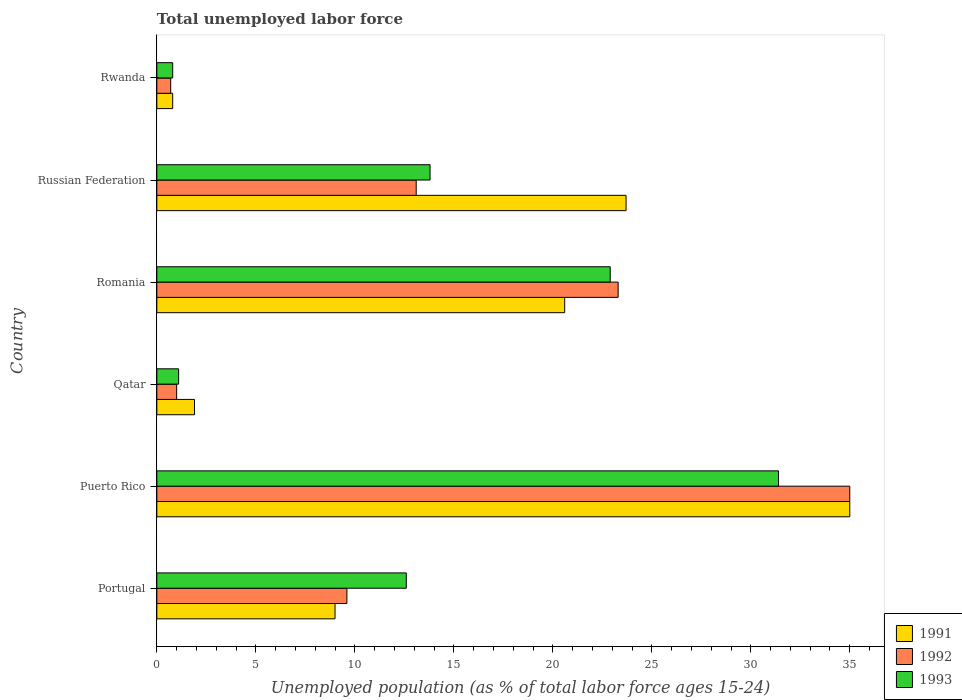How many different coloured bars are there?
Your response must be concise. 3. Are the number of bars on each tick of the Y-axis equal?
Offer a very short reply. Yes. How many bars are there on the 1st tick from the bottom?
Your response must be concise. 3. What is the label of the 6th group of bars from the top?
Offer a very short reply. Portugal. Across all countries, what is the maximum percentage of unemployed population in in 1993?
Your answer should be very brief. 31.4. Across all countries, what is the minimum percentage of unemployed population in in 1991?
Your response must be concise. 0.8. In which country was the percentage of unemployed population in in 1993 maximum?
Provide a short and direct response. Puerto Rico. In which country was the percentage of unemployed population in in 1993 minimum?
Give a very brief answer. Rwanda. What is the total percentage of unemployed population in in 1992 in the graph?
Your response must be concise. 82.7. What is the difference between the percentage of unemployed population in in 1992 in Russian Federation and that in Rwanda?
Your answer should be very brief. 12.4. What is the difference between the percentage of unemployed population in in 1992 in Romania and the percentage of unemployed population in in 1991 in Rwanda?
Offer a very short reply. 22.5. What is the average percentage of unemployed population in in 1991 per country?
Offer a terse response. 15.17. What is the difference between the percentage of unemployed population in in 1993 and percentage of unemployed population in in 1991 in Puerto Rico?
Offer a terse response. -3.6. In how many countries, is the percentage of unemployed population in in 1993 greater than 32 %?
Your response must be concise. 0. What is the ratio of the percentage of unemployed population in in 1993 in Romania to that in Rwanda?
Your answer should be compact. 28.62. Is the percentage of unemployed population in in 1992 in Qatar less than that in Romania?
Offer a terse response. Yes. Is the difference between the percentage of unemployed population in in 1993 in Portugal and Puerto Rico greater than the difference between the percentage of unemployed population in in 1991 in Portugal and Puerto Rico?
Ensure brevity in your answer.  Yes. What is the difference between the highest and the second highest percentage of unemployed population in in 1992?
Offer a terse response. 11.7. What is the difference between the highest and the lowest percentage of unemployed population in in 1991?
Provide a short and direct response. 34.2. What does the 3rd bar from the top in Rwanda represents?
Ensure brevity in your answer.  1991. How many countries are there in the graph?
Provide a succinct answer. 6. Are the values on the major ticks of X-axis written in scientific E-notation?
Your answer should be very brief. No. Does the graph contain any zero values?
Provide a succinct answer. No. Where does the legend appear in the graph?
Offer a terse response. Bottom right. How many legend labels are there?
Make the answer very short. 3. What is the title of the graph?
Offer a very short reply. Total unemployed labor force. Does "2015" appear as one of the legend labels in the graph?
Your response must be concise. No. What is the label or title of the X-axis?
Keep it short and to the point. Unemployed population (as % of total labor force ages 15-24). What is the Unemployed population (as % of total labor force ages 15-24) of 1991 in Portugal?
Provide a succinct answer. 9. What is the Unemployed population (as % of total labor force ages 15-24) of 1992 in Portugal?
Your answer should be very brief. 9.6. What is the Unemployed population (as % of total labor force ages 15-24) in 1993 in Portugal?
Give a very brief answer. 12.6. What is the Unemployed population (as % of total labor force ages 15-24) of 1992 in Puerto Rico?
Provide a succinct answer. 35. What is the Unemployed population (as % of total labor force ages 15-24) of 1993 in Puerto Rico?
Ensure brevity in your answer.  31.4. What is the Unemployed population (as % of total labor force ages 15-24) of 1991 in Qatar?
Provide a succinct answer. 1.9. What is the Unemployed population (as % of total labor force ages 15-24) of 1993 in Qatar?
Give a very brief answer. 1.1. What is the Unemployed population (as % of total labor force ages 15-24) in 1991 in Romania?
Offer a very short reply. 20.6. What is the Unemployed population (as % of total labor force ages 15-24) in 1992 in Romania?
Offer a terse response. 23.3. What is the Unemployed population (as % of total labor force ages 15-24) in 1993 in Romania?
Give a very brief answer. 22.9. What is the Unemployed population (as % of total labor force ages 15-24) in 1991 in Russian Federation?
Your response must be concise. 23.7. What is the Unemployed population (as % of total labor force ages 15-24) in 1992 in Russian Federation?
Your answer should be very brief. 13.1. What is the Unemployed population (as % of total labor force ages 15-24) of 1993 in Russian Federation?
Give a very brief answer. 13.8. What is the Unemployed population (as % of total labor force ages 15-24) in 1991 in Rwanda?
Offer a terse response. 0.8. What is the Unemployed population (as % of total labor force ages 15-24) in 1992 in Rwanda?
Give a very brief answer. 0.7. What is the Unemployed population (as % of total labor force ages 15-24) of 1993 in Rwanda?
Make the answer very short. 0.8. Across all countries, what is the maximum Unemployed population (as % of total labor force ages 15-24) in 1991?
Your answer should be compact. 35. Across all countries, what is the maximum Unemployed population (as % of total labor force ages 15-24) in 1993?
Make the answer very short. 31.4. Across all countries, what is the minimum Unemployed population (as % of total labor force ages 15-24) in 1991?
Your answer should be very brief. 0.8. Across all countries, what is the minimum Unemployed population (as % of total labor force ages 15-24) of 1992?
Offer a very short reply. 0.7. Across all countries, what is the minimum Unemployed population (as % of total labor force ages 15-24) of 1993?
Give a very brief answer. 0.8. What is the total Unemployed population (as % of total labor force ages 15-24) of 1991 in the graph?
Offer a terse response. 91. What is the total Unemployed population (as % of total labor force ages 15-24) of 1992 in the graph?
Offer a very short reply. 82.7. What is the total Unemployed population (as % of total labor force ages 15-24) of 1993 in the graph?
Ensure brevity in your answer.  82.6. What is the difference between the Unemployed population (as % of total labor force ages 15-24) in 1991 in Portugal and that in Puerto Rico?
Provide a short and direct response. -26. What is the difference between the Unemployed population (as % of total labor force ages 15-24) in 1992 in Portugal and that in Puerto Rico?
Give a very brief answer. -25.4. What is the difference between the Unemployed population (as % of total labor force ages 15-24) of 1993 in Portugal and that in Puerto Rico?
Your response must be concise. -18.8. What is the difference between the Unemployed population (as % of total labor force ages 15-24) of 1991 in Portugal and that in Qatar?
Offer a terse response. 7.1. What is the difference between the Unemployed population (as % of total labor force ages 15-24) in 1991 in Portugal and that in Romania?
Keep it short and to the point. -11.6. What is the difference between the Unemployed population (as % of total labor force ages 15-24) of 1992 in Portugal and that in Romania?
Your response must be concise. -13.7. What is the difference between the Unemployed population (as % of total labor force ages 15-24) in 1993 in Portugal and that in Romania?
Offer a terse response. -10.3. What is the difference between the Unemployed population (as % of total labor force ages 15-24) of 1991 in Portugal and that in Russian Federation?
Provide a short and direct response. -14.7. What is the difference between the Unemployed population (as % of total labor force ages 15-24) of 1992 in Portugal and that in Russian Federation?
Keep it short and to the point. -3.5. What is the difference between the Unemployed population (as % of total labor force ages 15-24) of 1991 in Portugal and that in Rwanda?
Make the answer very short. 8.2. What is the difference between the Unemployed population (as % of total labor force ages 15-24) of 1991 in Puerto Rico and that in Qatar?
Offer a terse response. 33.1. What is the difference between the Unemployed population (as % of total labor force ages 15-24) of 1993 in Puerto Rico and that in Qatar?
Make the answer very short. 30.3. What is the difference between the Unemployed population (as % of total labor force ages 15-24) of 1991 in Puerto Rico and that in Romania?
Your response must be concise. 14.4. What is the difference between the Unemployed population (as % of total labor force ages 15-24) of 1992 in Puerto Rico and that in Romania?
Provide a succinct answer. 11.7. What is the difference between the Unemployed population (as % of total labor force ages 15-24) in 1993 in Puerto Rico and that in Romania?
Your response must be concise. 8.5. What is the difference between the Unemployed population (as % of total labor force ages 15-24) in 1991 in Puerto Rico and that in Russian Federation?
Offer a terse response. 11.3. What is the difference between the Unemployed population (as % of total labor force ages 15-24) in 1992 in Puerto Rico and that in Russian Federation?
Your answer should be very brief. 21.9. What is the difference between the Unemployed population (as % of total labor force ages 15-24) of 1991 in Puerto Rico and that in Rwanda?
Make the answer very short. 34.2. What is the difference between the Unemployed population (as % of total labor force ages 15-24) of 1992 in Puerto Rico and that in Rwanda?
Your answer should be compact. 34.3. What is the difference between the Unemployed population (as % of total labor force ages 15-24) of 1993 in Puerto Rico and that in Rwanda?
Your answer should be compact. 30.6. What is the difference between the Unemployed population (as % of total labor force ages 15-24) of 1991 in Qatar and that in Romania?
Give a very brief answer. -18.7. What is the difference between the Unemployed population (as % of total labor force ages 15-24) in 1992 in Qatar and that in Romania?
Your response must be concise. -22.3. What is the difference between the Unemployed population (as % of total labor force ages 15-24) in 1993 in Qatar and that in Romania?
Make the answer very short. -21.8. What is the difference between the Unemployed population (as % of total labor force ages 15-24) in 1991 in Qatar and that in Russian Federation?
Your response must be concise. -21.8. What is the difference between the Unemployed population (as % of total labor force ages 15-24) in 1993 in Qatar and that in Russian Federation?
Your answer should be compact. -12.7. What is the difference between the Unemployed population (as % of total labor force ages 15-24) of 1991 in Qatar and that in Rwanda?
Keep it short and to the point. 1.1. What is the difference between the Unemployed population (as % of total labor force ages 15-24) of 1991 in Romania and that in Russian Federation?
Give a very brief answer. -3.1. What is the difference between the Unemployed population (as % of total labor force ages 15-24) in 1993 in Romania and that in Russian Federation?
Provide a short and direct response. 9.1. What is the difference between the Unemployed population (as % of total labor force ages 15-24) in 1991 in Romania and that in Rwanda?
Offer a terse response. 19.8. What is the difference between the Unemployed population (as % of total labor force ages 15-24) in 1992 in Romania and that in Rwanda?
Provide a succinct answer. 22.6. What is the difference between the Unemployed population (as % of total labor force ages 15-24) in 1993 in Romania and that in Rwanda?
Make the answer very short. 22.1. What is the difference between the Unemployed population (as % of total labor force ages 15-24) of 1991 in Russian Federation and that in Rwanda?
Your response must be concise. 22.9. What is the difference between the Unemployed population (as % of total labor force ages 15-24) of 1992 in Russian Federation and that in Rwanda?
Offer a terse response. 12.4. What is the difference between the Unemployed population (as % of total labor force ages 15-24) in 1993 in Russian Federation and that in Rwanda?
Your answer should be very brief. 13. What is the difference between the Unemployed population (as % of total labor force ages 15-24) in 1991 in Portugal and the Unemployed population (as % of total labor force ages 15-24) in 1993 in Puerto Rico?
Keep it short and to the point. -22.4. What is the difference between the Unemployed population (as % of total labor force ages 15-24) in 1992 in Portugal and the Unemployed population (as % of total labor force ages 15-24) in 1993 in Puerto Rico?
Offer a very short reply. -21.8. What is the difference between the Unemployed population (as % of total labor force ages 15-24) of 1992 in Portugal and the Unemployed population (as % of total labor force ages 15-24) of 1993 in Qatar?
Give a very brief answer. 8.5. What is the difference between the Unemployed population (as % of total labor force ages 15-24) of 1991 in Portugal and the Unemployed population (as % of total labor force ages 15-24) of 1992 in Romania?
Your answer should be compact. -14.3. What is the difference between the Unemployed population (as % of total labor force ages 15-24) of 1991 in Portugal and the Unemployed population (as % of total labor force ages 15-24) of 1992 in Russian Federation?
Keep it short and to the point. -4.1. What is the difference between the Unemployed population (as % of total labor force ages 15-24) of 1991 in Portugal and the Unemployed population (as % of total labor force ages 15-24) of 1993 in Rwanda?
Your answer should be very brief. 8.2. What is the difference between the Unemployed population (as % of total labor force ages 15-24) in 1992 in Portugal and the Unemployed population (as % of total labor force ages 15-24) in 1993 in Rwanda?
Keep it short and to the point. 8.8. What is the difference between the Unemployed population (as % of total labor force ages 15-24) of 1991 in Puerto Rico and the Unemployed population (as % of total labor force ages 15-24) of 1992 in Qatar?
Provide a short and direct response. 34. What is the difference between the Unemployed population (as % of total labor force ages 15-24) of 1991 in Puerto Rico and the Unemployed population (as % of total labor force ages 15-24) of 1993 in Qatar?
Make the answer very short. 33.9. What is the difference between the Unemployed population (as % of total labor force ages 15-24) in 1992 in Puerto Rico and the Unemployed population (as % of total labor force ages 15-24) in 1993 in Qatar?
Provide a short and direct response. 33.9. What is the difference between the Unemployed population (as % of total labor force ages 15-24) of 1991 in Puerto Rico and the Unemployed population (as % of total labor force ages 15-24) of 1992 in Romania?
Make the answer very short. 11.7. What is the difference between the Unemployed population (as % of total labor force ages 15-24) of 1991 in Puerto Rico and the Unemployed population (as % of total labor force ages 15-24) of 1992 in Russian Federation?
Provide a succinct answer. 21.9. What is the difference between the Unemployed population (as % of total labor force ages 15-24) in 1991 in Puerto Rico and the Unemployed population (as % of total labor force ages 15-24) in 1993 in Russian Federation?
Offer a terse response. 21.2. What is the difference between the Unemployed population (as % of total labor force ages 15-24) of 1992 in Puerto Rico and the Unemployed population (as % of total labor force ages 15-24) of 1993 in Russian Federation?
Your answer should be very brief. 21.2. What is the difference between the Unemployed population (as % of total labor force ages 15-24) of 1991 in Puerto Rico and the Unemployed population (as % of total labor force ages 15-24) of 1992 in Rwanda?
Keep it short and to the point. 34.3. What is the difference between the Unemployed population (as % of total labor force ages 15-24) in 1991 in Puerto Rico and the Unemployed population (as % of total labor force ages 15-24) in 1993 in Rwanda?
Provide a short and direct response. 34.2. What is the difference between the Unemployed population (as % of total labor force ages 15-24) in 1992 in Puerto Rico and the Unemployed population (as % of total labor force ages 15-24) in 1993 in Rwanda?
Provide a succinct answer. 34.2. What is the difference between the Unemployed population (as % of total labor force ages 15-24) of 1991 in Qatar and the Unemployed population (as % of total labor force ages 15-24) of 1992 in Romania?
Offer a terse response. -21.4. What is the difference between the Unemployed population (as % of total labor force ages 15-24) in 1992 in Qatar and the Unemployed population (as % of total labor force ages 15-24) in 1993 in Romania?
Ensure brevity in your answer.  -21.9. What is the difference between the Unemployed population (as % of total labor force ages 15-24) in 1991 in Qatar and the Unemployed population (as % of total labor force ages 15-24) in 1992 in Russian Federation?
Make the answer very short. -11.2. What is the difference between the Unemployed population (as % of total labor force ages 15-24) of 1991 in Qatar and the Unemployed population (as % of total labor force ages 15-24) of 1993 in Rwanda?
Offer a terse response. 1.1. What is the difference between the Unemployed population (as % of total labor force ages 15-24) in 1992 in Qatar and the Unemployed population (as % of total labor force ages 15-24) in 1993 in Rwanda?
Offer a terse response. 0.2. What is the difference between the Unemployed population (as % of total labor force ages 15-24) of 1991 in Romania and the Unemployed population (as % of total labor force ages 15-24) of 1992 in Russian Federation?
Give a very brief answer. 7.5. What is the difference between the Unemployed population (as % of total labor force ages 15-24) in 1992 in Romania and the Unemployed population (as % of total labor force ages 15-24) in 1993 in Russian Federation?
Make the answer very short. 9.5. What is the difference between the Unemployed population (as % of total labor force ages 15-24) of 1991 in Romania and the Unemployed population (as % of total labor force ages 15-24) of 1993 in Rwanda?
Keep it short and to the point. 19.8. What is the difference between the Unemployed population (as % of total labor force ages 15-24) of 1991 in Russian Federation and the Unemployed population (as % of total labor force ages 15-24) of 1992 in Rwanda?
Your response must be concise. 23. What is the difference between the Unemployed population (as % of total labor force ages 15-24) of 1991 in Russian Federation and the Unemployed population (as % of total labor force ages 15-24) of 1993 in Rwanda?
Ensure brevity in your answer.  22.9. What is the average Unemployed population (as % of total labor force ages 15-24) of 1991 per country?
Offer a very short reply. 15.17. What is the average Unemployed population (as % of total labor force ages 15-24) in 1992 per country?
Give a very brief answer. 13.78. What is the average Unemployed population (as % of total labor force ages 15-24) in 1993 per country?
Ensure brevity in your answer.  13.77. What is the difference between the Unemployed population (as % of total labor force ages 15-24) in 1991 and Unemployed population (as % of total labor force ages 15-24) in 1992 in Portugal?
Make the answer very short. -0.6. What is the difference between the Unemployed population (as % of total labor force ages 15-24) of 1991 and Unemployed population (as % of total labor force ages 15-24) of 1993 in Puerto Rico?
Ensure brevity in your answer.  3.6. What is the difference between the Unemployed population (as % of total labor force ages 15-24) of 1992 and Unemployed population (as % of total labor force ages 15-24) of 1993 in Puerto Rico?
Offer a terse response. 3.6. What is the difference between the Unemployed population (as % of total labor force ages 15-24) of 1991 and Unemployed population (as % of total labor force ages 15-24) of 1993 in Qatar?
Provide a succinct answer. 0.8. What is the difference between the Unemployed population (as % of total labor force ages 15-24) of 1992 and Unemployed population (as % of total labor force ages 15-24) of 1993 in Qatar?
Your response must be concise. -0.1. What is the difference between the Unemployed population (as % of total labor force ages 15-24) in 1991 and Unemployed population (as % of total labor force ages 15-24) in 1993 in Romania?
Ensure brevity in your answer.  -2.3. What is the difference between the Unemployed population (as % of total labor force ages 15-24) of 1992 and Unemployed population (as % of total labor force ages 15-24) of 1993 in Russian Federation?
Offer a terse response. -0.7. What is the difference between the Unemployed population (as % of total labor force ages 15-24) in 1992 and Unemployed population (as % of total labor force ages 15-24) in 1993 in Rwanda?
Provide a succinct answer. -0.1. What is the ratio of the Unemployed population (as % of total labor force ages 15-24) of 1991 in Portugal to that in Puerto Rico?
Your answer should be very brief. 0.26. What is the ratio of the Unemployed population (as % of total labor force ages 15-24) of 1992 in Portugal to that in Puerto Rico?
Give a very brief answer. 0.27. What is the ratio of the Unemployed population (as % of total labor force ages 15-24) in 1993 in Portugal to that in Puerto Rico?
Make the answer very short. 0.4. What is the ratio of the Unemployed population (as % of total labor force ages 15-24) of 1991 in Portugal to that in Qatar?
Offer a very short reply. 4.74. What is the ratio of the Unemployed population (as % of total labor force ages 15-24) in 1993 in Portugal to that in Qatar?
Make the answer very short. 11.45. What is the ratio of the Unemployed population (as % of total labor force ages 15-24) of 1991 in Portugal to that in Romania?
Your answer should be compact. 0.44. What is the ratio of the Unemployed population (as % of total labor force ages 15-24) in 1992 in Portugal to that in Romania?
Offer a terse response. 0.41. What is the ratio of the Unemployed population (as % of total labor force ages 15-24) in 1993 in Portugal to that in Romania?
Your answer should be very brief. 0.55. What is the ratio of the Unemployed population (as % of total labor force ages 15-24) of 1991 in Portugal to that in Russian Federation?
Provide a succinct answer. 0.38. What is the ratio of the Unemployed population (as % of total labor force ages 15-24) in 1992 in Portugal to that in Russian Federation?
Provide a short and direct response. 0.73. What is the ratio of the Unemployed population (as % of total labor force ages 15-24) in 1991 in Portugal to that in Rwanda?
Your answer should be compact. 11.25. What is the ratio of the Unemployed population (as % of total labor force ages 15-24) in 1992 in Portugal to that in Rwanda?
Ensure brevity in your answer.  13.71. What is the ratio of the Unemployed population (as % of total labor force ages 15-24) in 1993 in Portugal to that in Rwanda?
Provide a short and direct response. 15.75. What is the ratio of the Unemployed population (as % of total labor force ages 15-24) of 1991 in Puerto Rico to that in Qatar?
Offer a terse response. 18.42. What is the ratio of the Unemployed population (as % of total labor force ages 15-24) of 1993 in Puerto Rico to that in Qatar?
Provide a short and direct response. 28.55. What is the ratio of the Unemployed population (as % of total labor force ages 15-24) of 1991 in Puerto Rico to that in Romania?
Ensure brevity in your answer.  1.7. What is the ratio of the Unemployed population (as % of total labor force ages 15-24) in 1992 in Puerto Rico to that in Romania?
Your answer should be compact. 1.5. What is the ratio of the Unemployed population (as % of total labor force ages 15-24) of 1993 in Puerto Rico to that in Romania?
Your answer should be very brief. 1.37. What is the ratio of the Unemployed population (as % of total labor force ages 15-24) of 1991 in Puerto Rico to that in Russian Federation?
Ensure brevity in your answer.  1.48. What is the ratio of the Unemployed population (as % of total labor force ages 15-24) of 1992 in Puerto Rico to that in Russian Federation?
Keep it short and to the point. 2.67. What is the ratio of the Unemployed population (as % of total labor force ages 15-24) in 1993 in Puerto Rico to that in Russian Federation?
Provide a short and direct response. 2.28. What is the ratio of the Unemployed population (as % of total labor force ages 15-24) in 1991 in Puerto Rico to that in Rwanda?
Ensure brevity in your answer.  43.75. What is the ratio of the Unemployed population (as % of total labor force ages 15-24) of 1993 in Puerto Rico to that in Rwanda?
Your answer should be very brief. 39.25. What is the ratio of the Unemployed population (as % of total labor force ages 15-24) in 1991 in Qatar to that in Romania?
Give a very brief answer. 0.09. What is the ratio of the Unemployed population (as % of total labor force ages 15-24) of 1992 in Qatar to that in Romania?
Keep it short and to the point. 0.04. What is the ratio of the Unemployed population (as % of total labor force ages 15-24) in 1993 in Qatar to that in Romania?
Offer a terse response. 0.05. What is the ratio of the Unemployed population (as % of total labor force ages 15-24) in 1991 in Qatar to that in Russian Federation?
Give a very brief answer. 0.08. What is the ratio of the Unemployed population (as % of total labor force ages 15-24) of 1992 in Qatar to that in Russian Federation?
Offer a very short reply. 0.08. What is the ratio of the Unemployed population (as % of total labor force ages 15-24) of 1993 in Qatar to that in Russian Federation?
Provide a short and direct response. 0.08. What is the ratio of the Unemployed population (as % of total labor force ages 15-24) of 1991 in Qatar to that in Rwanda?
Provide a short and direct response. 2.38. What is the ratio of the Unemployed population (as % of total labor force ages 15-24) in 1992 in Qatar to that in Rwanda?
Offer a terse response. 1.43. What is the ratio of the Unemployed population (as % of total labor force ages 15-24) in 1993 in Qatar to that in Rwanda?
Give a very brief answer. 1.38. What is the ratio of the Unemployed population (as % of total labor force ages 15-24) of 1991 in Romania to that in Russian Federation?
Offer a terse response. 0.87. What is the ratio of the Unemployed population (as % of total labor force ages 15-24) of 1992 in Romania to that in Russian Federation?
Keep it short and to the point. 1.78. What is the ratio of the Unemployed population (as % of total labor force ages 15-24) in 1993 in Romania to that in Russian Federation?
Offer a terse response. 1.66. What is the ratio of the Unemployed population (as % of total labor force ages 15-24) of 1991 in Romania to that in Rwanda?
Ensure brevity in your answer.  25.75. What is the ratio of the Unemployed population (as % of total labor force ages 15-24) in 1992 in Romania to that in Rwanda?
Your response must be concise. 33.29. What is the ratio of the Unemployed population (as % of total labor force ages 15-24) of 1993 in Romania to that in Rwanda?
Your answer should be compact. 28.62. What is the ratio of the Unemployed population (as % of total labor force ages 15-24) of 1991 in Russian Federation to that in Rwanda?
Give a very brief answer. 29.62. What is the ratio of the Unemployed population (as % of total labor force ages 15-24) of 1992 in Russian Federation to that in Rwanda?
Your answer should be very brief. 18.71. What is the ratio of the Unemployed population (as % of total labor force ages 15-24) of 1993 in Russian Federation to that in Rwanda?
Your response must be concise. 17.25. What is the difference between the highest and the second highest Unemployed population (as % of total labor force ages 15-24) in 1991?
Provide a short and direct response. 11.3. What is the difference between the highest and the second highest Unemployed population (as % of total labor force ages 15-24) of 1992?
Provide a succinct answer. 11.7. What is the difference between the highest and the lowest Unemployed population (as % of total labor force ages 15-24) of 1991?
Keep it short and to the point. 34.2. What is the difference between the highest and the lowest Unemployed population (as % of total labor force ages 15-24) of 1992?
Make the answer very short. 34.3. What is the difference between the highest and the lowest Unemployed population (as % of total labor force ages 15-24) of 1993?
Offer a very short reply. 30.6. 